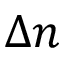<formula> <loc_0><loc_0><loc_500><loc_500>{ \Delta } n</formula> 